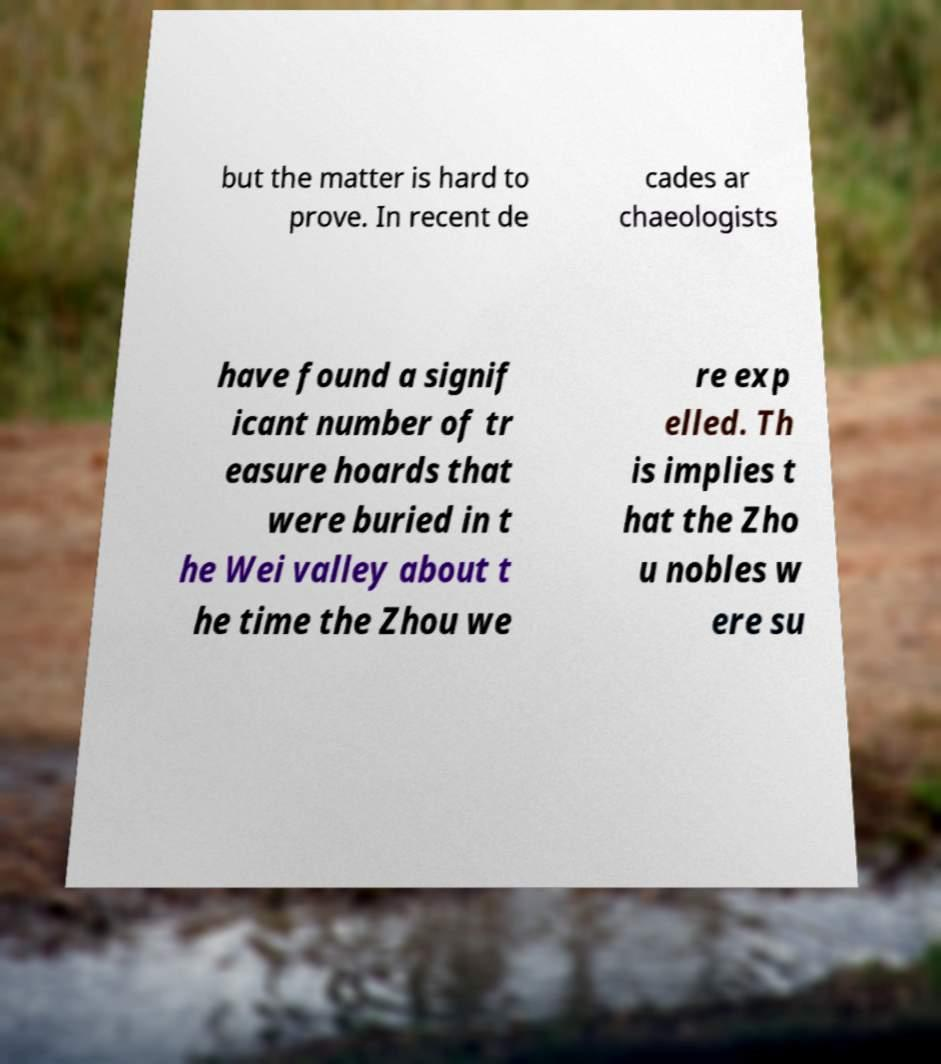Could you extract and type out the text from this image? but the matter is hard to prove. In recent de cades ar chaeologists have found a signif icant number of tr easure hoards that were buried in t he Wei valley about t he time the Zhou we re exp elled. Th is implies t hat the Zho u nobles w ere su 